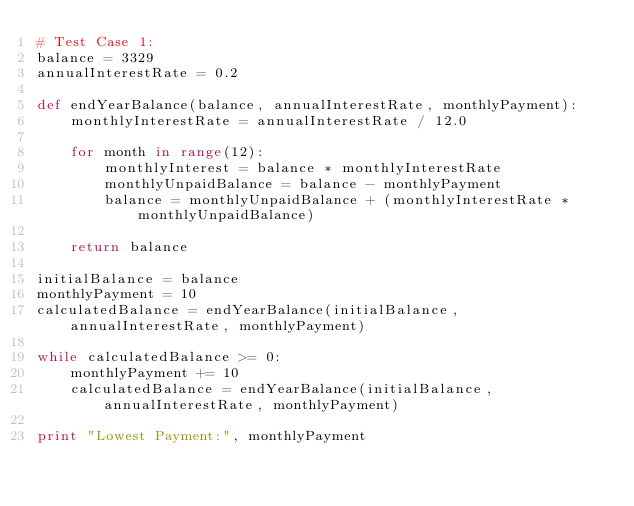<code> <loc_0><loc_0><loc_500><loc_500><_Python_># Test Case 1:
balance = 3329
annualInterestRate = 0.2

def endYearBalance(balance, annualInterestRate, monthlyPayment):
    monthlyInterestRate = annualInterestRate / 12.0

    for month in range(12):
        monthlyInterest = balance * monthlyInterestRate
        monthlyUnpaidBalance = balance - monthlyPayment
        balance = monthlyUnpaidBalance + (monthlyInterestRate * monthlyUnpaidBalance)

    return balance

initialBalance = balance
monthlyPayment = 10
calculatedBalance = endYearBalance(initialBalance, annualInterestRate, monthlyPayment)

while calculatedBalance >= 0:
    monthlyPayment += 10
    calculatedBalance = endYearBalance(initialBalance, annualInterestRate, monthlyPayment)

print "Lowest Payment:", monthlyPayment
</code> 